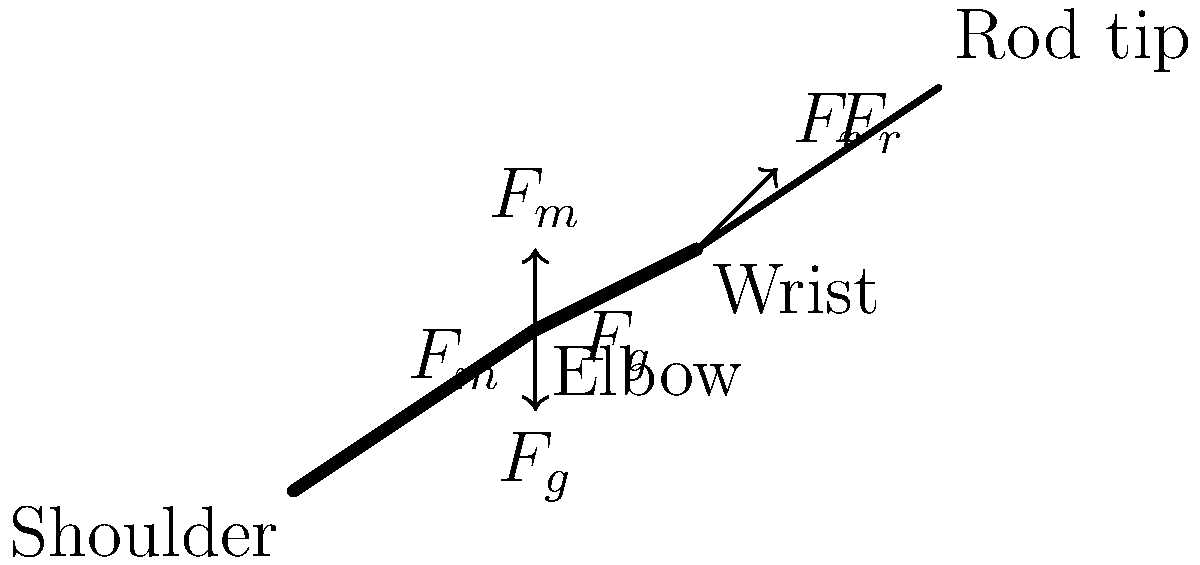A fisherman in Rogaland is casting a fishing rod. The muscle force ($F_m$) acting on the forearm is 50 N, the gravitational force ($F_g$) on the forearm is 20 N, and the reaction force from the fishing rod ($F_r$) is 30 N. Assuming the forearm is at a 30-degree angle with the horizontal, what is the net torque about the elbow joint? To solve this problem, we need to follow these steps:

1. Identify the forces acting on the forearm:
   - Muscle force ($F_m$) = 50 N (upward)
   - Gravitational force ($F_g$) = 20 N (downward)
   - Reaction force from fishing rod ($F_r$) = 30 N (at an angle)

2. Determine the moment arm for each force:
   - For $F_m$: $r_m = L \sin(90°) = L$, where $L$ is the length of the forearm
   - For $F_g$: $r_g = \frac{L}{2} \cos(30°)$, assuming the center of mass is at the middle of the forearm
   - For $F_r$: $r_r = L \cos(30°)$

3. Calculate the torque for each force:
   - $\tau_m = F_m \cdot r_m = 50L$ (clockwise, positive)
   - $\tau_g = F_g \cdot r_g = 20 \cdot \frac{L}{2} \cos(30°) = 8.66L$ (counterclockwise, negative)
   - $\tau_r = F_r \cdot r_r = 30L \cos(30°) = 25.98L$ (counterclockwise, negative)

4. Sum up the torques to find the net torque:
   $\tau_{net} = \tau_m - \tau_g - \tau_r$
   $\tau_{net} = 50L - 8.66L - 25.98L$
   $\tau_{net} = 15.36L$

The net torque is positive, indicating a clockwise rotation about the elbow joint.
Answer: $15.36L$ N⋅m (clockwise) 